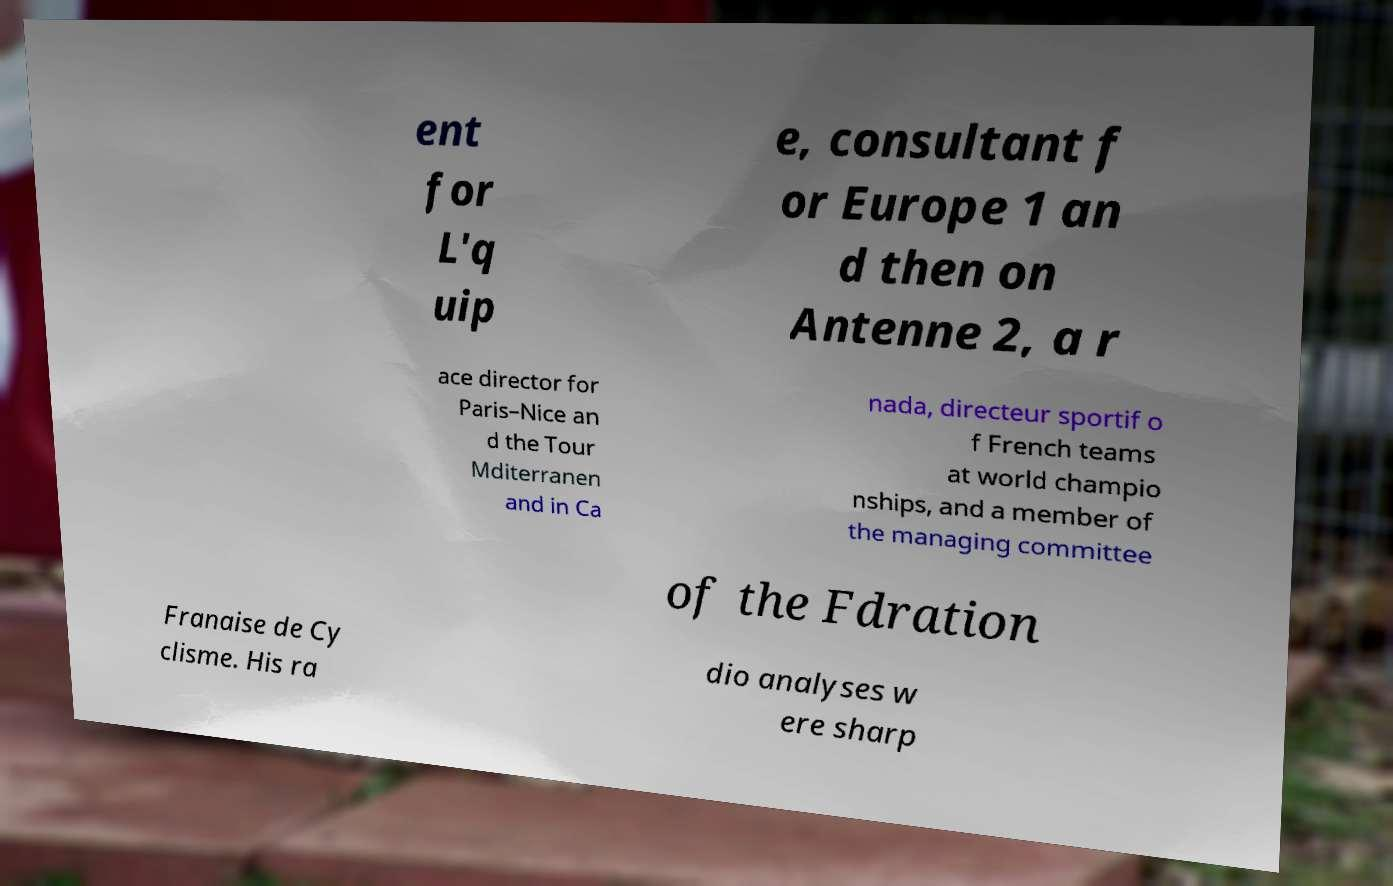What messages or text are displayed in this image? I need them in a readable, typed format. ent for L'q uip e, consultant f or Europe 1 an d then on Antenne 2, a r ace director for Paris–Nice an d the Tour Mditerranen and in Ca nada, directeur sportif o f French teams at world champio nships, and a member of the managing committee of the Fdration Franaise de Cy clisme. His ra dio analyses w ere sharp 